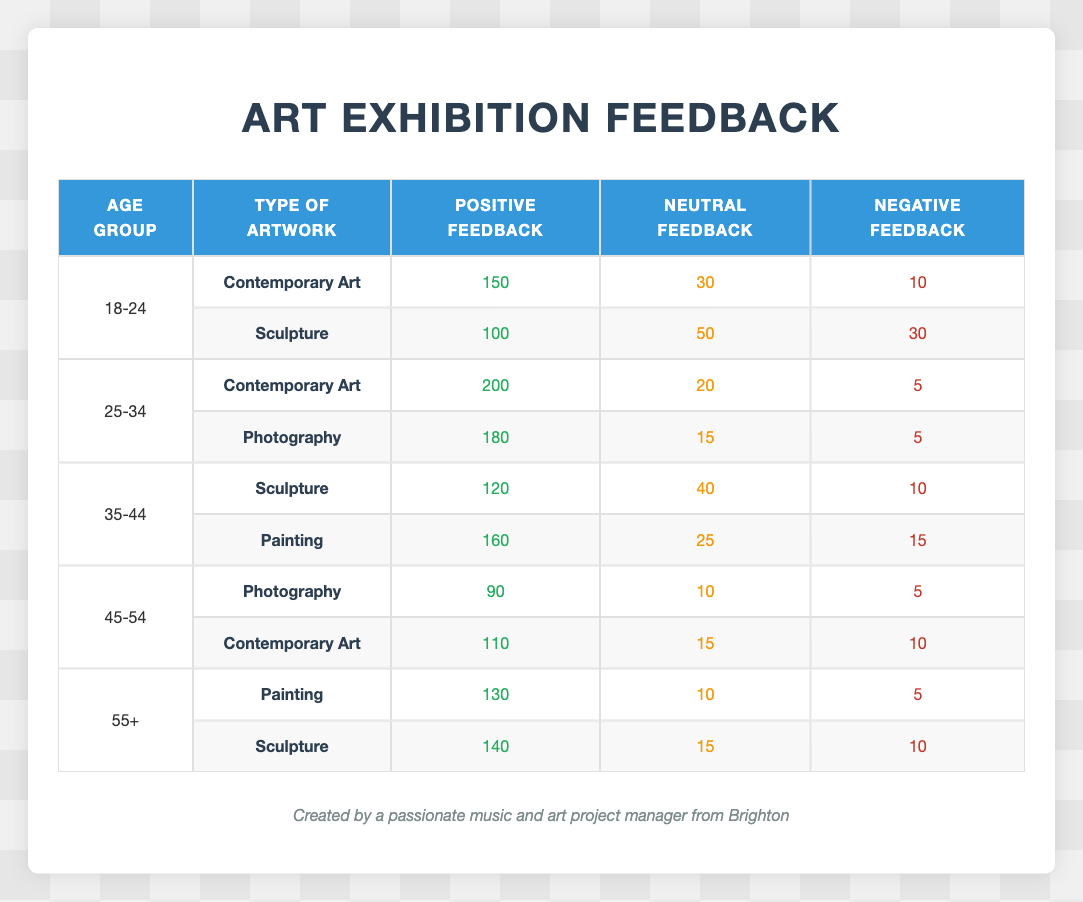What's the total positive feedback for Contemporary Art across all age groups? To find the total positive feedback for Contemporary Art, we sum the positive feedback values from all relevant rows: 150 (18-24) + 200 (25-34) + 110 (45-54) = 460.
Answer: 460 Which age group gave the most negative feedback for Sculpture? From the table, the negative feedback for Sculpture is: 10 (35-44) and 30 (18-24). The higher is 30 from the 18-24 age group, so they gave the most negative feedback for Sculpture.
Answer: 18-24 Is the neutral feedback for Painting higher than that for Photography across all age groups? To assess this, we review the neutral feedback: Painting has 25 (35-44) and 10 (55+), totaling 35. Photography has 15 (25-34) and 10 (45-54), totaling 25. Since 35 > 25, we conclude that Painting has higher neutral feedback than Photography.
Answer: Yes What is the average positive feedback for the 45-54 age group? The positive feedback for the 45-54 age group includes: 90 (Photography) + 110 (Contemporary Art) = 200. There are 2 entries, so the average positive feedback is 200/2 = 100.
Answer: 100 How many total feedback responses were recorded for the 55+ age group? For the 55+ age group, the feedback entries are 130 (Painting) + 140 (Sculpture). Adding these gives us the total: 130 + 140 = 270.
Answer: 270 Was there any age group that rated Sculpture with more positive feedback than any Painting? Analyzing the feedback, Sculpture received 120 (35-44) and 140 (55+), whereas Painting received 160 (35-44) and 130 (55+). Since 140 (Sculpture) < 160 (Painting), there is no age group that gave more positive feedback for Sculpture than for Painting.
Answer: No What percentage of the feedback for Photography from the 45-54 age group was negative? The negative feedback for Photography in the 45-54 group is 5, with the total feedback being 90 (positive) + 10 (neutral) + 5 (negative) = 105. The negative percentage is (5/105) * 100 ≈ 4.76%.
Answer: Approximately 4.76% Which type of artwork received the least positive feedback overall? Reviewing the positive feedback values: 150 (Contemporary), 100 (Sculpture), 200 (Contemporary), 180 (Photography), 120 (Sculpture), 160 (Painting), 90 (Photography), 110 (Contemporary), 130 (Painting), and 140 (Sculpture). The least is 90 from Photography in the 45-54 age group.
Answer: Photography (45-54) 